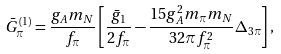Convert formula to latex. <formula><loc_0><loc_0><loc_500><loc_500>\bar { G } ^ { ( 1 ) } _ { \pi } = \frac { g _ { A } m _ { N } } { f _ { \pi } } \left [ \frac { \bar { g } _ { 1 } } { 2 f _ { \pi } } - \frac { 1 5 g _ { A } ^ { 2 } m _ { \pi } m _ { N } } { 3 2 \pi f _ { \pi } ^ { 2 } } \Delta _ { 3 \pi } \right ] ,</formula> 